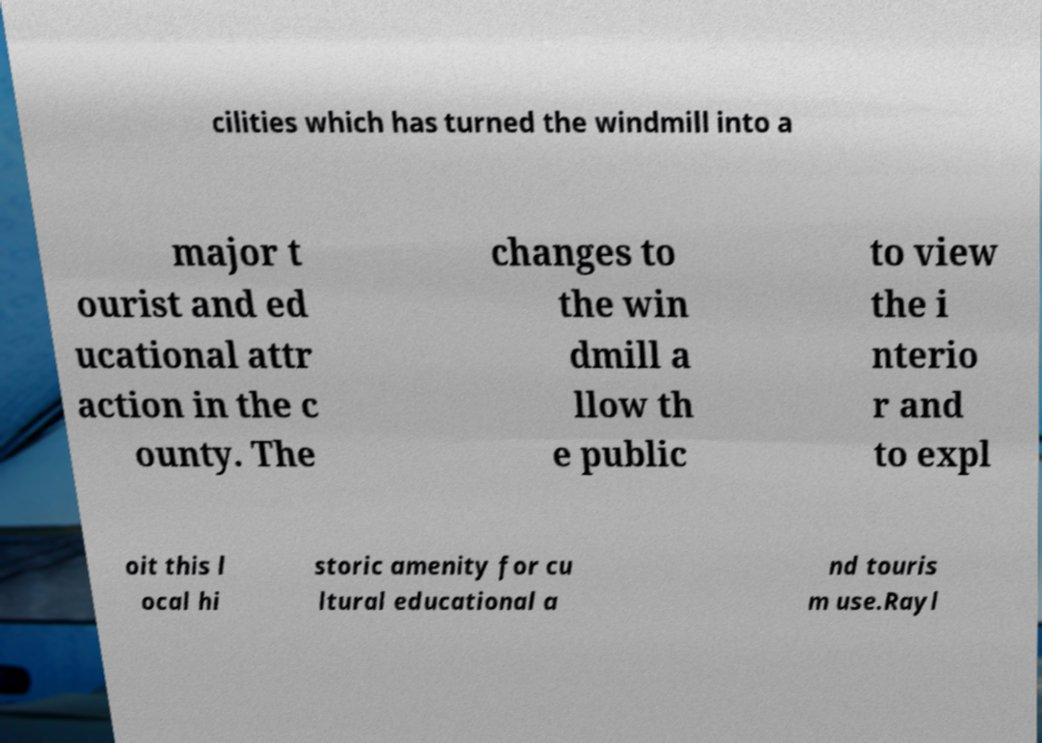For documentation purposes, I need the text within this image transcribed. Could you provide that? cilities which has turned the windmill into a major t ourist and ed ucational attr action in the c ounty. The changes to the win dmill a llow th e public to view the i nterio r and to expl oit this l ocal hi storic amenity for cu ltural educational a nd touris m use.Rayl 